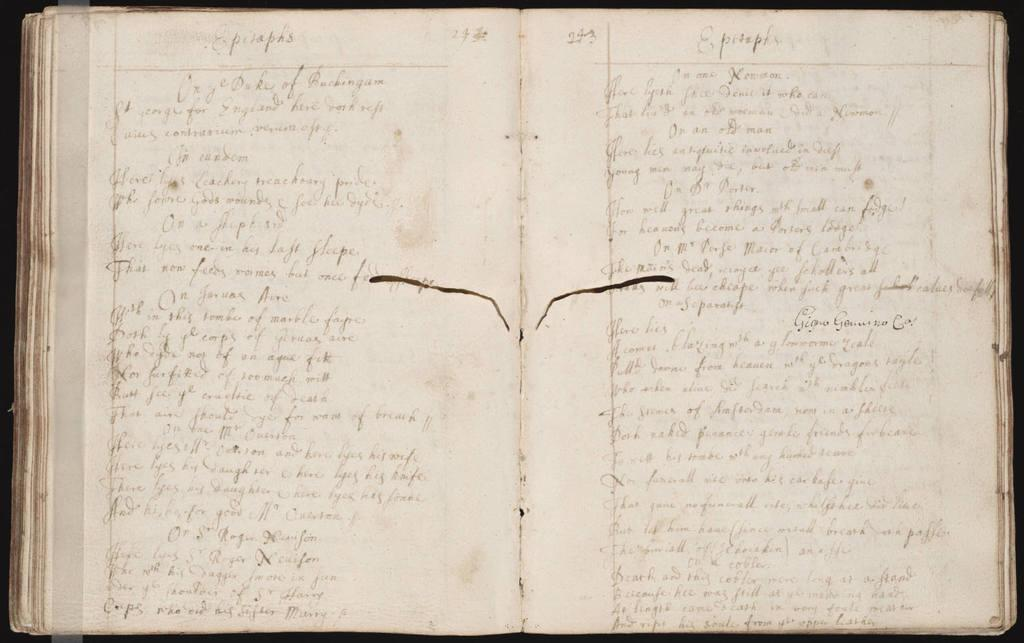<image>
Give a short and clear explanation of the subsequent image. An open notebook with pages written in cursive writing fill the pages mentioning feelings about people as if this is a diary. 